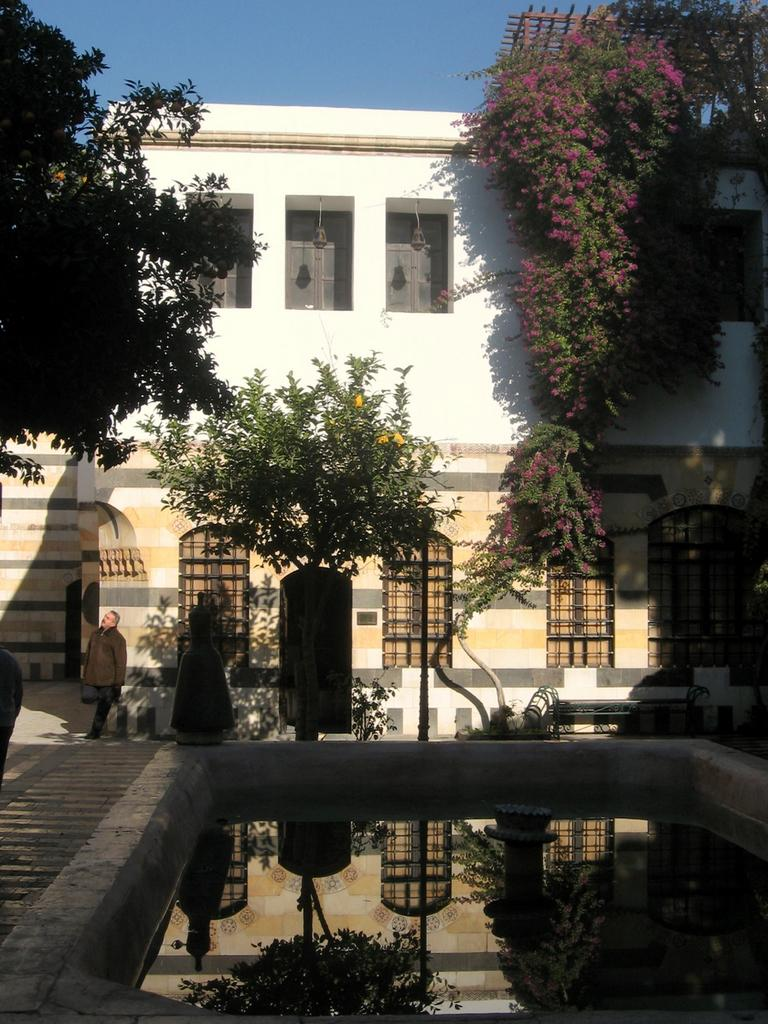What type of structure is present in the image? There is a building in the image. What is the color of the building? The building is white. What other natural elements can be seen in the image? There are trees in the image. What is the color of the trees? The trees are green. Can you describe the person in the image? The person is wearing a brown jacket. What is visible in the background of the image? The sky is visible in the image. What is the color of the sky? The sky is blue. What type of army is marching through the trees in the image? There is no army present in the image; it only features a building, trees, a person, and the sky. How many feet are visible in the image? There is no specific mention of feet in the image; it only shows a building, trees, a person, and the sky. 